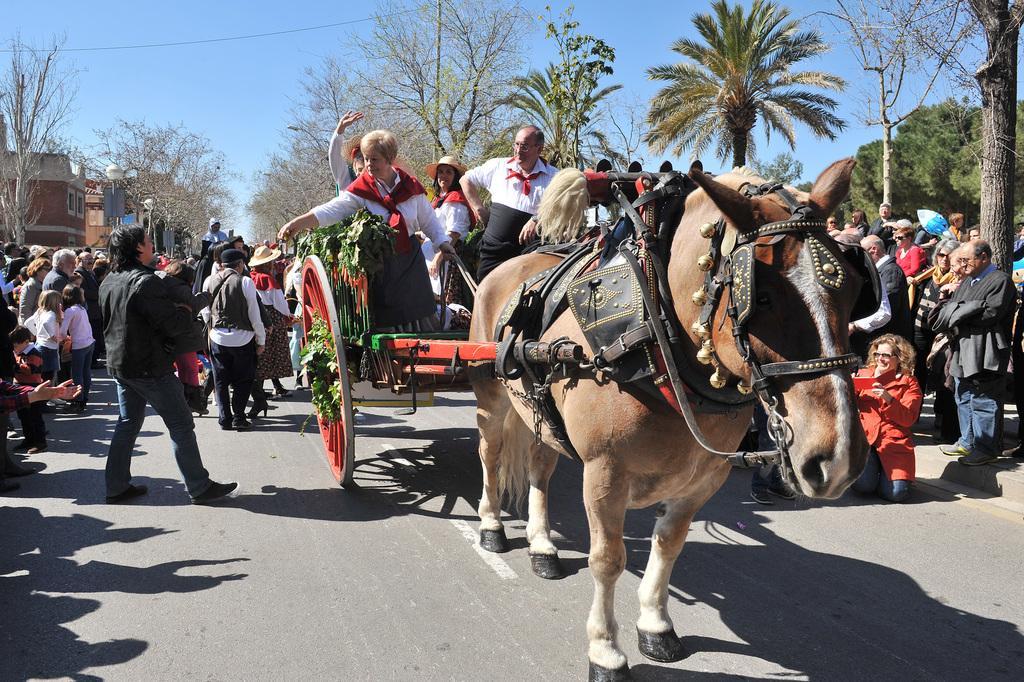How would you summarize this image in a sentence or two? In the foreground of the picture I can see horse cart on the road and I can see a few people in the cart. There is a group of people on the road. In the background, I can see the buildings and trees. There are clouds in the sky. 